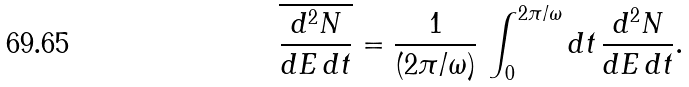<formula> <loc_0><loc_0><loc_500><loc_500>\overline { \frac { d ^ { 2 } N } { d E \, d t } } = { \frac { 1 } { ( 2 \pi / \omega ) } } \, \int _ { 0 } ^ { 2 \pi / \omega } d t \, { \frac { d ^ { 2 } N } { d E \, d t } } .</formula> 